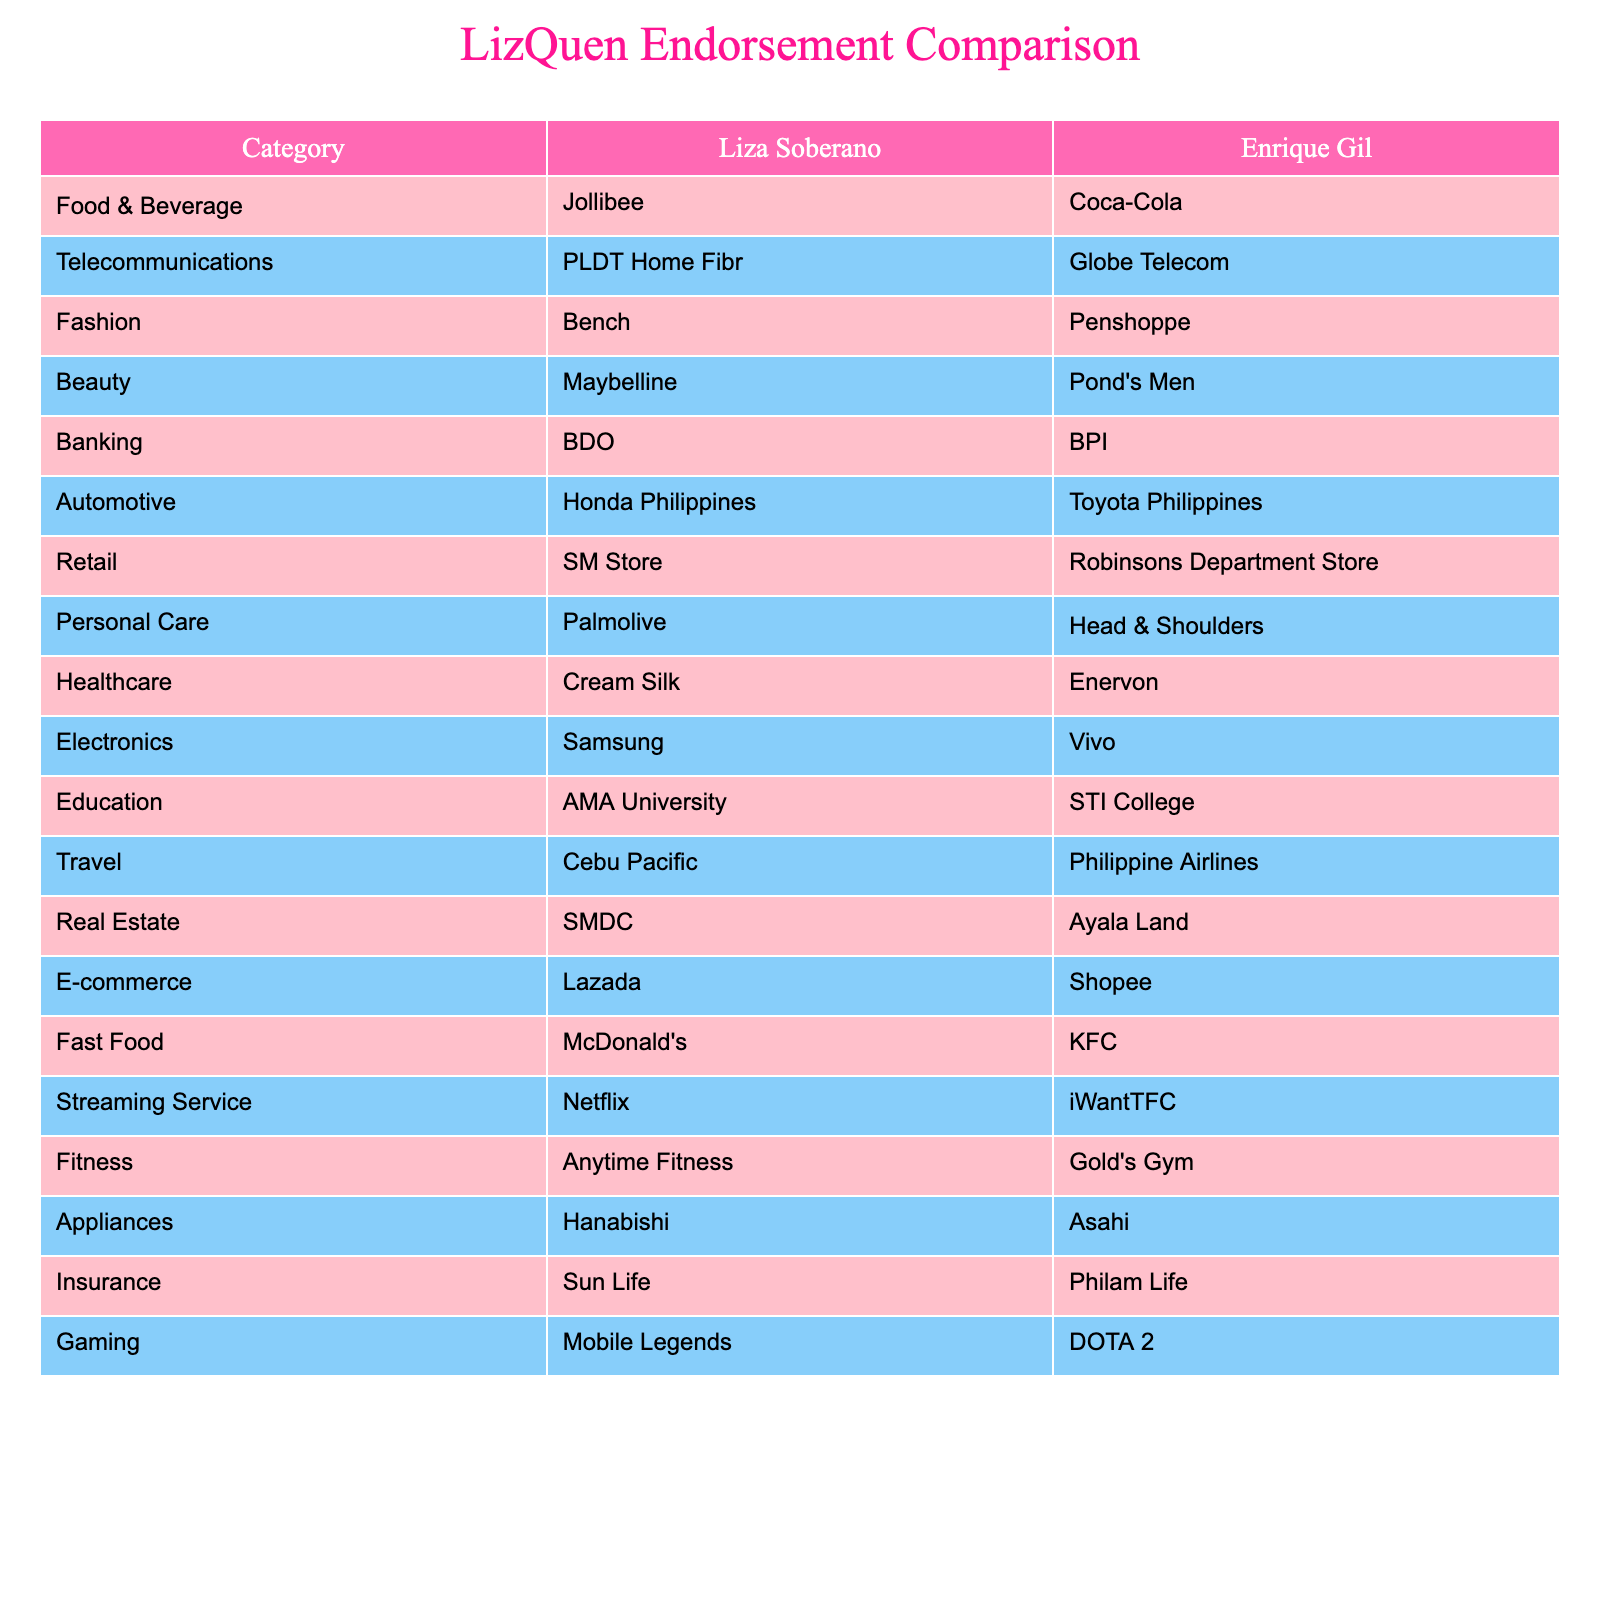What endorsement deal does Liza Soberano have in the automotive category? According to the table, Liza Soberano endorses Honda Philippines in the automotive category.
Answer: Honda Philippines What is Enrique Gil's endorsement for the telecommunications category? The table shows that Enrique Gil endorses Globe Telecom in the telecommunications category.
Answer: Globe Telecom Which brands do both Liza Soberano and Enrique Gil endorse for personal care? Liza Soberano endorses Palmolive, while Enrique Gil endorses Head & Shoulders for personal care. These are different brands for each of them.
Answer: Different brands Does Liza Soberano have an endorsement deal in both the food & beverage and travel categories? Yes, in the food & beverage category, Liza endorses Jollibee, and in the travel category, she endorses Cebu Pacific. Therefore, she has endorsements in both categories.
Answer: Yes Which endorsement category does Enrique Gil not have but Liza Soberano does? Liza Soberano has an endorsement deal with Maybelline in the beauty category, which is not listed for Enrique Gil in the table. Therefore, this is a category that Liza has but Enrique does not.
Answer: Beauty Who has more endorsement deals in the electronics category? Both Liza Soberano and Enrique Gil have one endorsement each in the electronics category, with Liza endorsing Samsung and Enrique endorsing Vivo. Thus, neither has more than the other.
Answer: Neither What is the difference in endorsement categories between Liza Soberano and Enrique Gil? By carefully examining the table, each celebrity endorses different companies across various categories. Out of 20 categories, Liza and Enrique endorse in many of the same categories, but they also have unique endorsements. Liza has 10 unique categories, and Enrique has 10 unique categories, resulting in 20 total unique endorsements between them.
Answer: 20 total unique endorsements Which endorsement category features a fast food brand for both Liza Soberano and Enrique Gil? In the fast food category, Liza Soberano endorses McDonald's and Enrique Gil endorses KFC, which are different brands for this category.
Answer: Different brands Are there any categories where Liza Soberano and Enrique Gil have identical endorsement brands? Reviewing the table, there are no identical endorsement brands present for both Liza Soberano and Enrique Gil in any category. They both endorse separate brands across all listed categories.
Answer: No identical brands 